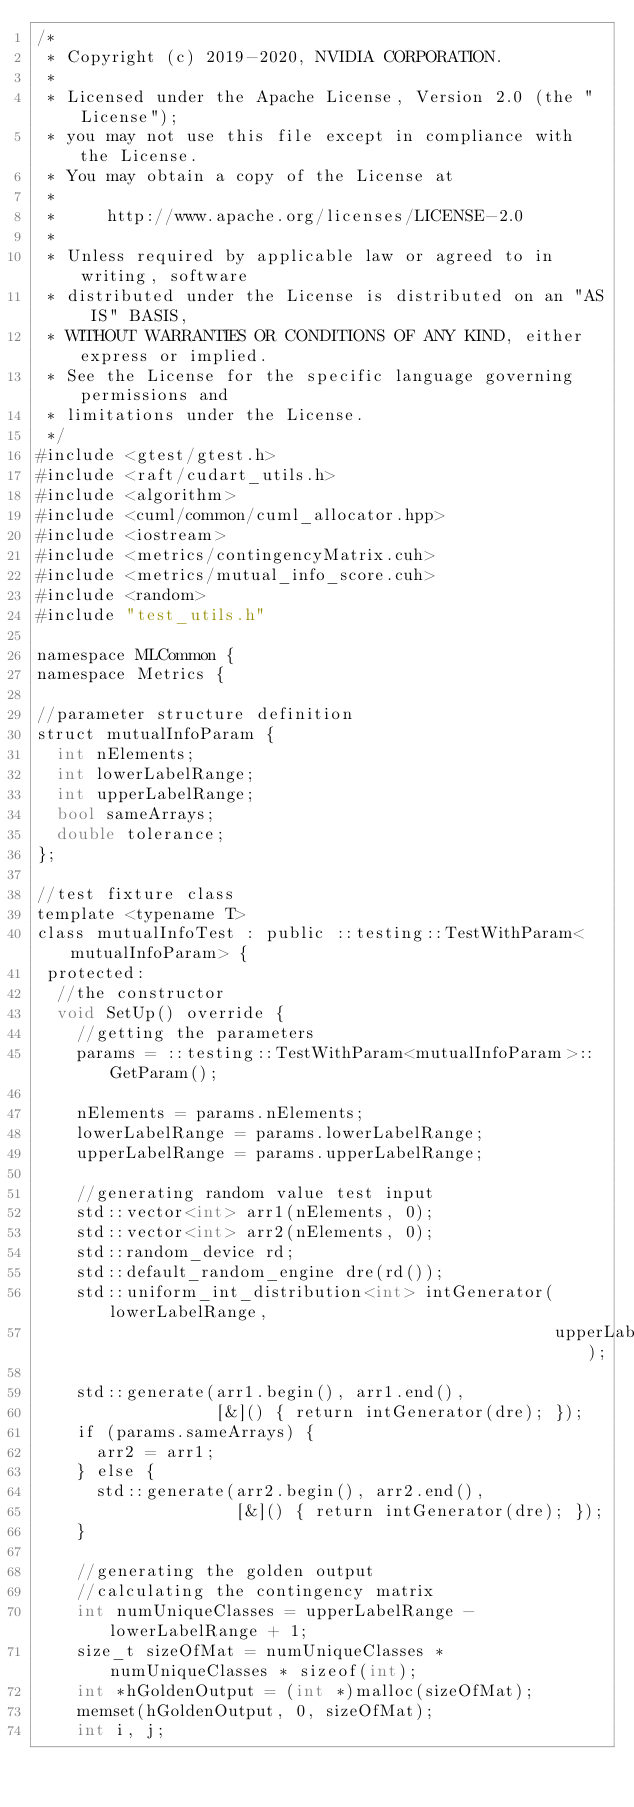<code> <loc_0><loc_0><loc_500><loc_500><_Cuda_>/*
 * Copyright (c) 2019-2020, NVIDIA CORPORATION.
 *
 * Licensed under the Apache License, Version 2.0 (the "License");
 * you may not use this file except in compliance with the License.
 * You may obtain a copy of the License at
 *
 *     http://www.apache.org/licenses/LICENSE-2.0
 *
 * Unless required by applicable law or agreed to in writing, software
 * distributed under the License is distributed on an "AS IS" BASIS,
 * WITHOUT WARRANTIES OR CONDITIONS OF ANY KIND, either express or implied.
 * See the License for the specific language governing permissions and
 * limitations under the License.
 */
#include <gtest/gtest.h>
#include <raft/cudart_utils.h>
#include <algorithm>
#include <cuml/common/cuml_allocator.hpp>
#include <iostream>
#include <metrics/contingencyMatrix.cuh>
#include <metrics/mutual_info_score.cuh>
#include <random>
#include "test_utils.h"

namespace MLCommon {
namespace Metrics {

//parameter structure definition
struct mutualInfoParam {
  int nElements;
  int lowerLabelRange;
  int upperLabelRange;
  bool sameArrays;
  double tolerance;
};

//test fixture class
template <typename T>
class mutualInfoTest : public ::testing::TestWithParam<mutualInfoParam> {
 protected:
  //the constructor
  void SetUp() override {
    //getting the parameters
    params = ::testing::TestWithParam<mutualInfoParam>::GetParam();

    nElements = params.nElements;
    lowerLabelRange = params.lowerLabelRange;
    upperLabelRange = params.upperLabelRange;

    //generating random value test input
    std::vector<int> arr1(nElements, 0);
    std::vector<int> arr2(nElements, 0);
    std::random_device rd;
    std::default_random_engine dre(rd());
    std::uniform_int_distribution<int> intGenerator(lowerLabelRange,
                                                    upperLabelRange);

    std::generate(arr1.begin(), arr1.end(),
                  [&]() { return intGenerator(dre); });
    if (params.sameArrays) {
      arr2 = arr1;
    } else {
      std::generate(arr2.begin(), arr2.end(),
                    [&]() { return intGenerator(dre); });
    }

    //generating the golden output
    //calculating the contingency matrix
    int numUniqueClasses = upperLabelRange - lowerLabelRange + 1;
    size_t sizeOfMat = numUniqueClasses * numUniqueClasses * sizeof(int);
    int *hGoldenOutput = (int *)malloc(sizeOfMat);
    memset(hGoldenOutput, 0, sizeOfMat);
    int i, j;</code> 